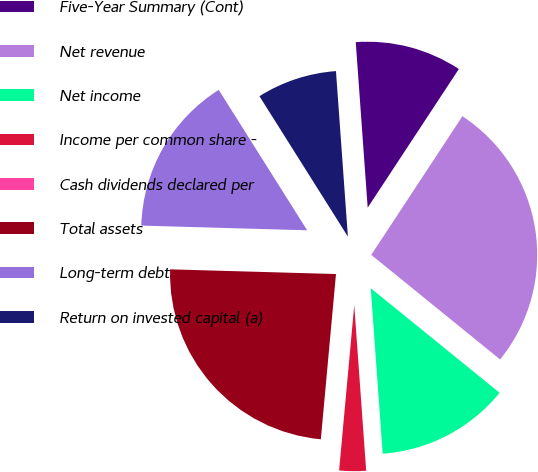Convert chart. <chart><loc_0><loc_0><loc_500><loc_500><pie_chart><fcel>Five-Year Summary (Cont)<fcel>Net revenue<fcel>Net income<fcel>Income per common share -<fcel>Cash dividends declared per<fcel>Total assets<fcel>Long-term debt<fcel>Return on invested capital (a)<nl><fcel>10.4%<fcel>26.59%<fcel>13.0%<fcel>2.6%<fcel>0.0%<fcel>23.99%<fcel>15.6%<fcel>7.8%<nl></chart> 